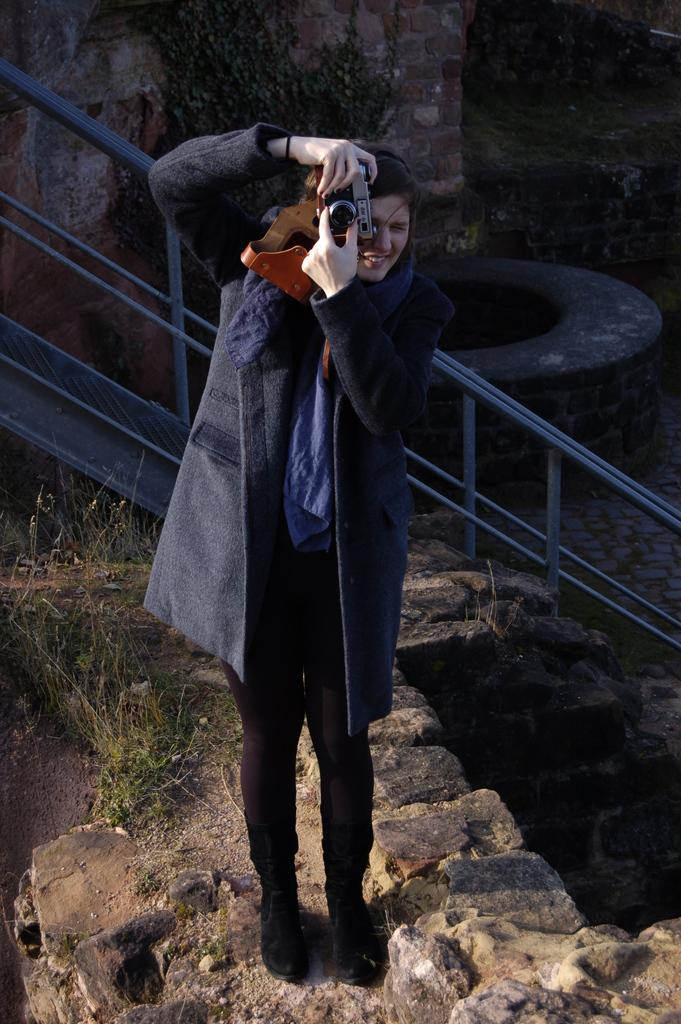What is the person in the image doing? The person is standing in the image. What is the person holding in the image? The person is holding a camera. What can be seen in the background of the image? There are rocks visible in the background of the image. What direction are the person's feet pointing in the image? The provided facts do not mention the direction of the person's feet, so it cannot be determined from the image. --- Facts: 1. There is a person sitting on a chair in the image. 2. The person is holding a book. 3. There is a table next to the chair. 4. There is a lamp on the table. Absurd Topics: ocean, dance, bird Conversation: What is the person in the image doing? The person is sitting on a chair in the image. What is the person holding in the image? The person is holding a book. What is located next to the chair in the image? There is a table next to the chair in the image. What is on the table in the image? There is a lamp on the table in the image. Reasoning: Let's think step by step in order to produce the conversation. We start by identifying the main subject in the image, which is the person sitting on a chair. Then, we describe what the person is holding, which is a book. Next, we mention the presence of a table next to the chair and describe what is on the table, which is a lamp. Each question is designed to elicit a specific detail about the image that is known from the provided facts. Absurd Question/Answer: Can you see any ocean waves in the image? There is no mention of an ocean or waves in the provided facts, so it cannot be determined from the image. 